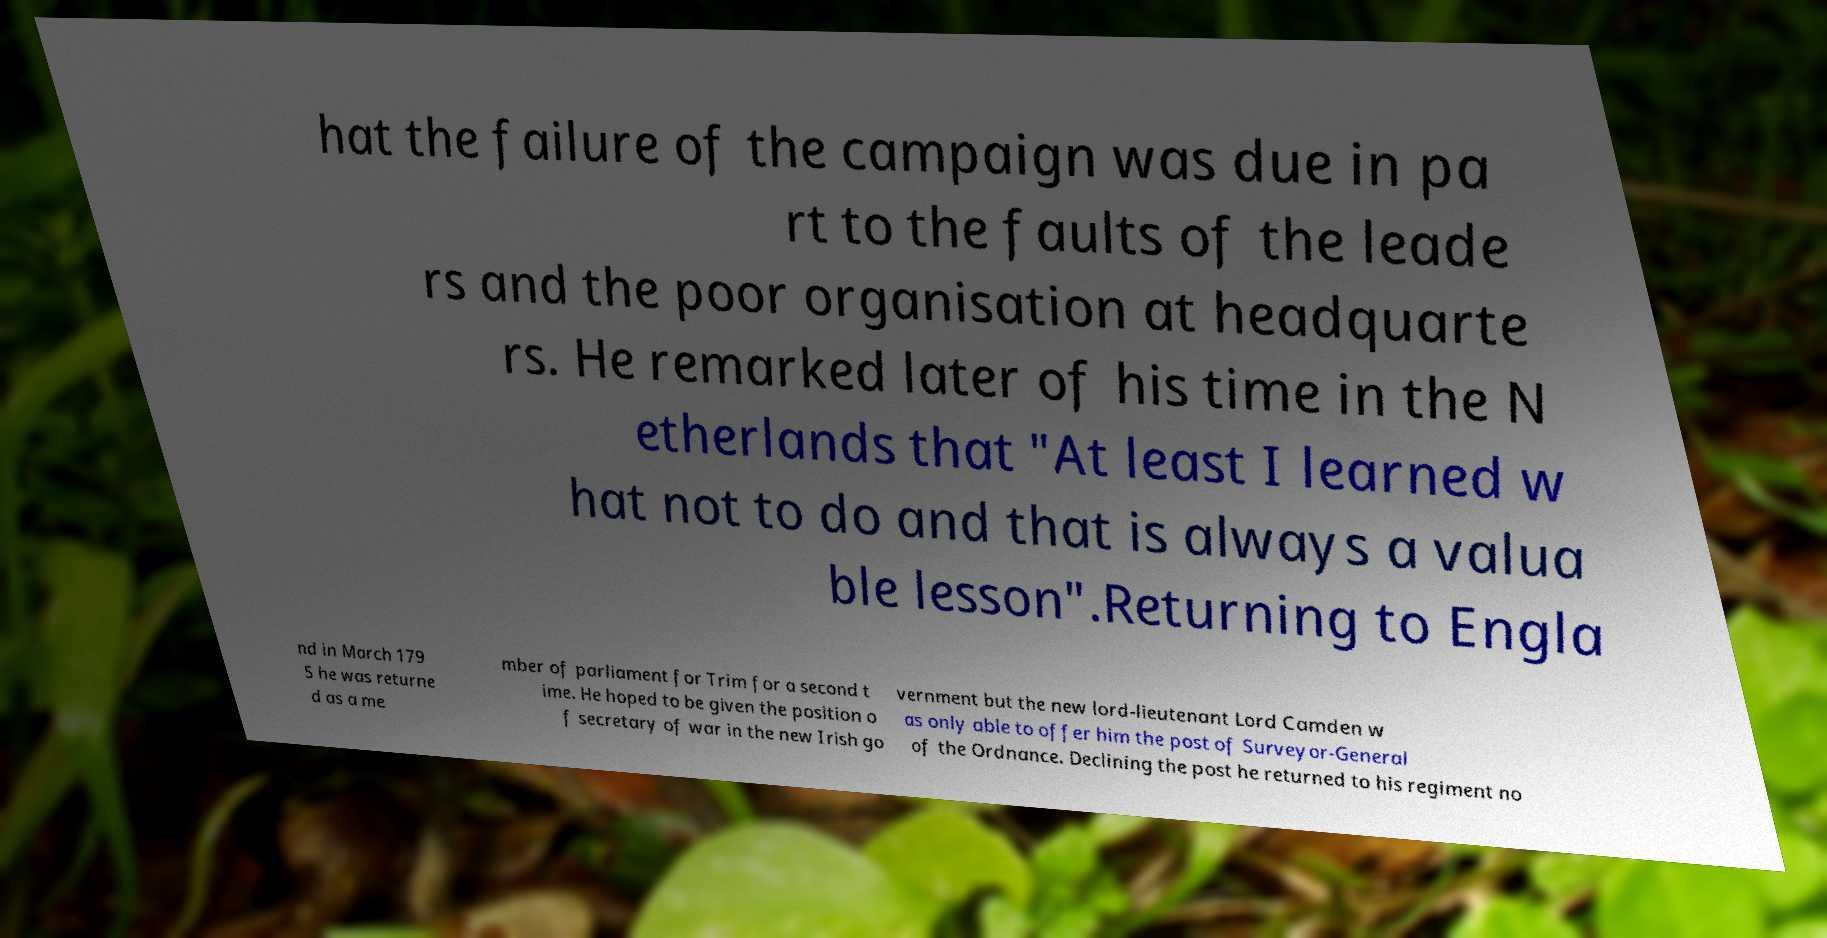Could you extract and type out the text from this image? hat the failure of the campaign was due in pa rt to the faults of the leade rs and the poor organisation at headquarte rs. He remarked later of his time in the N etherlands that "At least I learned w hat not to do and that is always a valua ble lesson".Returning to Engla nd in March 179 5 he was returne d as a me mber of parliament for Trim for a second t ime. He hoped to be given the position o f secretary of war in the new Irish go vernment but the new lord-lieutenant Lord Camden w as only able to offer him the post of Surveyor-General of the Ordnance. Declining the post he returned to his regiment no 